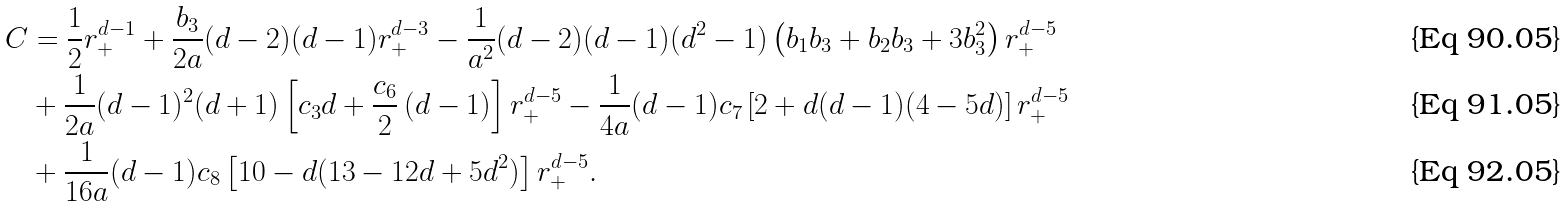<formula> <loc_0><loc_0><loc_500><loc_500>C & = \frac { 1 } { 2 } r _ { + } ^ { d - 1 } + \frac { b _ { 3 } } { 2 a } ( d - 2 ) ( d - 1 ) r _ { + } ^ { d - 3 } - \frac { 1 } { a ^ { 2 } } ( d - 2 ) ( d - 1 ) ( d ^ { 2 } - 1 ) \left ( b _ { 1 } b _ { 3 } + b _ { 2 } b _ { 3 } + 3 b _ { 3 } ^ { 2 } \right ) r _ { + } ^ { d - 5 } \\ & + \frac { 1 } { 2 a } ( d - 1 ) ^ { 2 } ( d + 1 ) \left [ c _ { 3 } d + \frac { c _ { 6 } } { 2 } \left ( d - 1 \right ) \right ] r _ { + } ^ { d - 5 } - \frac { 1 } { 4 a } ( d - 1 ) c _ { 7 } \left [ 2 + d ( d - 1 ) ( 4 - 5 d ) \right ] r _ { + } ^ { d - 5 } \\ & + \frac { 1 } { 1 6 a } ( d - 1 ) c _ { 8 } \left [ 1 0 - d ( 1 3 - 1 2 d + 5 d ^ { 2 } ) \right ] r _ { + } ^ { d - 5 } .</formula> 